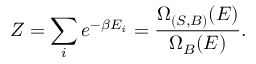Convert formula to latex. <formula><loc_0><loc_0><loc_500><loc_500>Z = \sum _ { i } e ^ { - \beta E _ { i } } = { \frac { \Omega _ { ( S , B ) } ( E ) } { \Omega _ { B } ( E ) } } .</formula> 